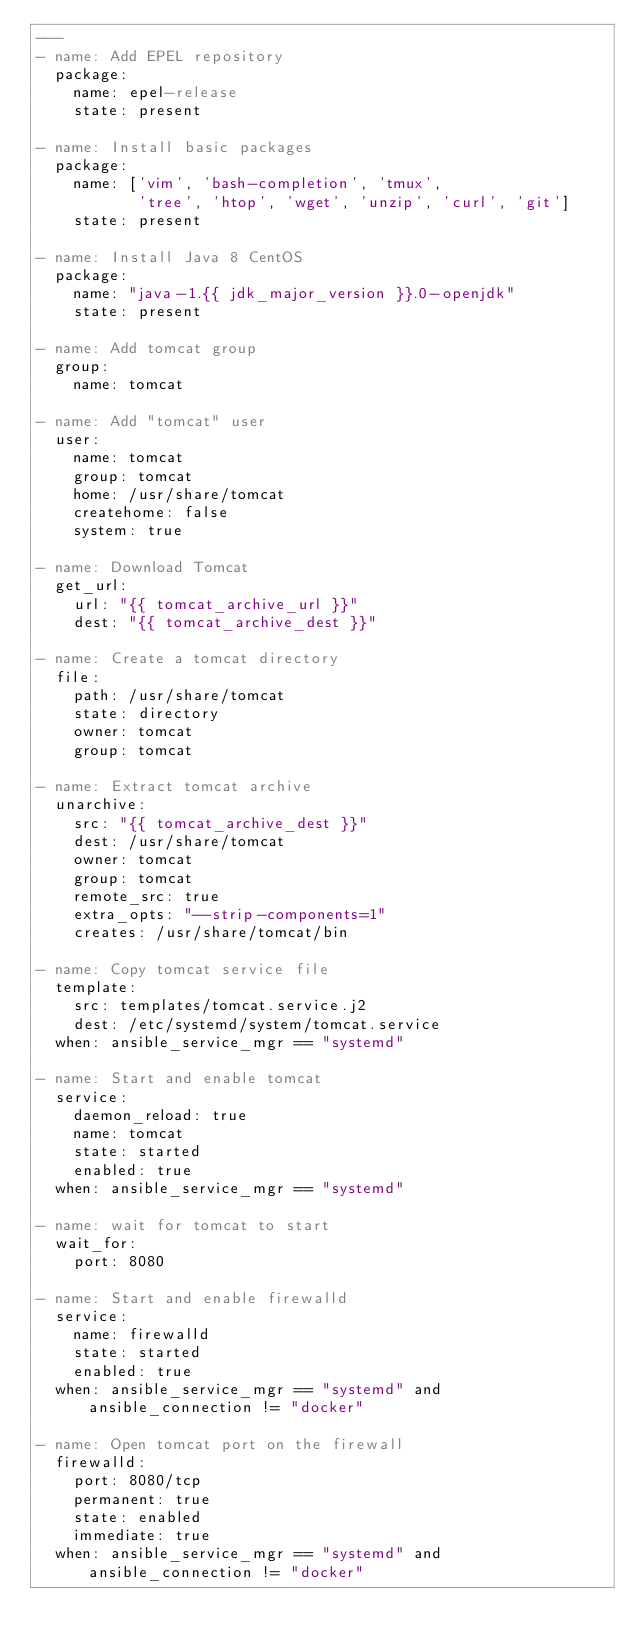Convert code to text. <code><loc_0><loc_0><loc_500><loc_500><_YAML_>---
- name: Add EPEL repository
  package:
    name: epel-release
    state: present

- name: Install basic packages
  package:
    name: ['vim', 'bash-completion', 'tmux',
           'tree', 'htop', 'wget', 'unzip', 'curl', 'git']
    state: present

- name: Install Java 8 CentOS
  package:
    name: "java-1.{{ jdk_major_version }}.0-openjdk"
    state: present

- name: Add tomcat group
  group:
    name: tomcat

- name: Add "tomcat" user
  user:
    name: tomcat
    group: tomcat
    home: /usr/share/tomcat
    createhome: false
    system: true

- name: Download Tomcat
  get_url:
    url: "{{ tomcat_archive_url }}"
    dest: "{{ tomcat_archive_dest }}"

- name: Create a tomcat directory
  file:
    path: /usr/share/tomcat
    state: directory
    owner: tomcat
    group: tomcat

- name: Extract tomcat archive
  unarchive:
    src: "{{ tomcat_archive_dest }}"
    dest: /usr/share/tomcat
    owner: tomcat
    group: tomcat
    remote_src: true
    extra_opts: "--strip-components=1"
    creates: /usr/share/tomcat/bin

- name: Copy tomcat service file
  template:
    src: templates/tomcat.service.j2
    dest: /etc/systemd/system/tomcat.service
  when: ansible_service_mgr == "systemd"

- name: Start and enable tomcat
  service:
    daemon_reload: true
    name: tomcat
    state: started
    enabled: true
  when: ansible_service_mgr == "systemd"

- name: wait for tomcat to start
  wait_for: 
    port: 8080

- name: Start and enable firewalld
  service:
    name: firewalld
    state: started
    enabled: true
  when: ansible_service_mgr == "systemd" and ansible_connection != "docker"

- name: Open tomcat port on the firewall
  firewalld:
    port: 8080/tcp
    permanent: true
    state: enabled
    immediate: true
  when: ansible_service_mgr == "systemd" and ansible_connection != "docker"
</code> 